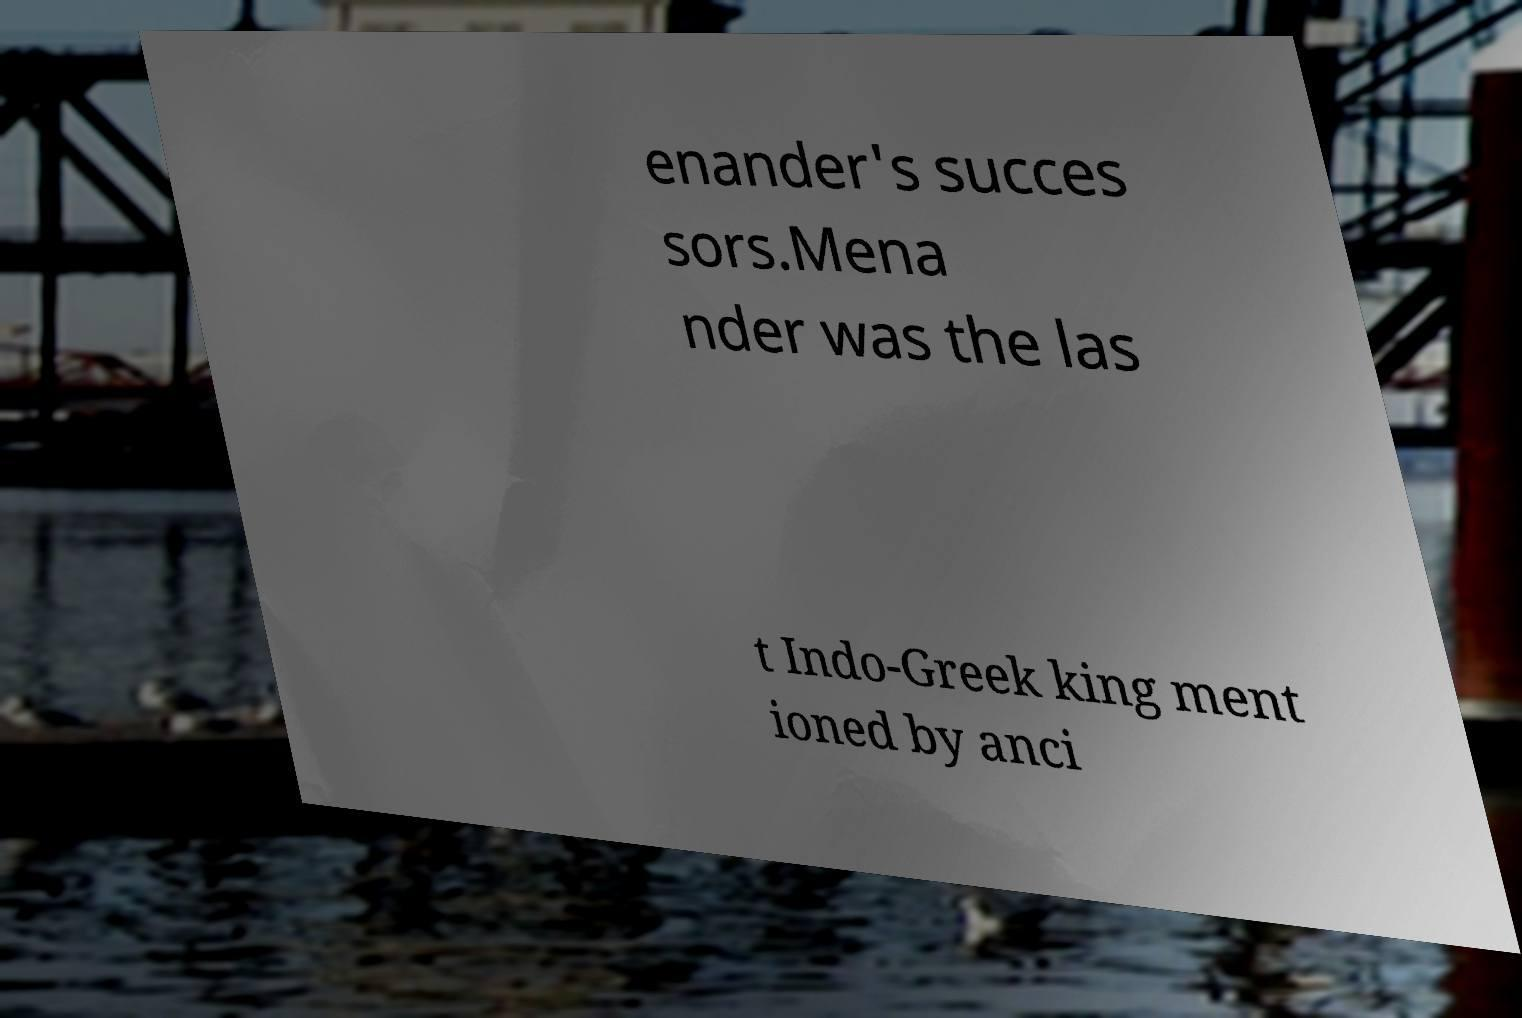Please read and relay the text visible in this image. What does it say? enander's succes sors.Mena nder was the las t Indo-Greek king ment ioned by anci 